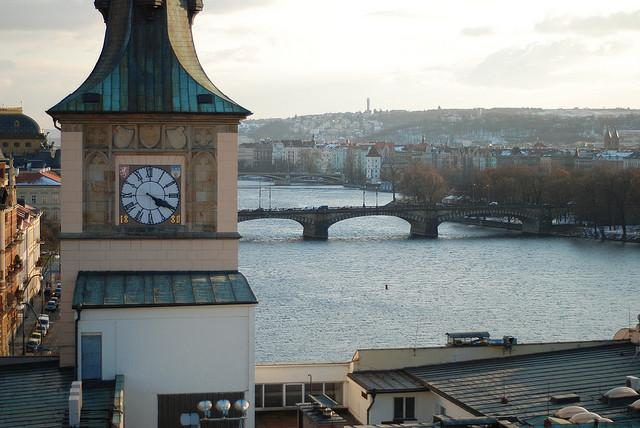What do the numbers on either side of the clock represent? Please explain your reasoning. date. The numbers on the face of the clock represent time. the numbers on the side represent when the clock tower was built. 